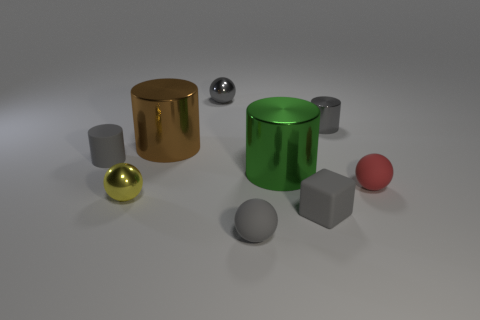Subtract all brown balls. How many gray cylinders are left? 2 Subtract all small yellow balls. How many balls are left? 3 Subtract all yellow balls. How many balls are left? 3 Subtract all blue spheres. Subtract all purple blocks. How many spheres are left? 4 Subtract all blocks. How many objects are left? 8 Add 8 tiny red objects. How many tiny red objects exist? 9 Subtract 0 cyan cylinders. How many objects are left? 9 Subtract all yellow metal things. Subtract all small rubber objects. How many objects are left? 4 Add 2 balls. How many balls are left? 6 